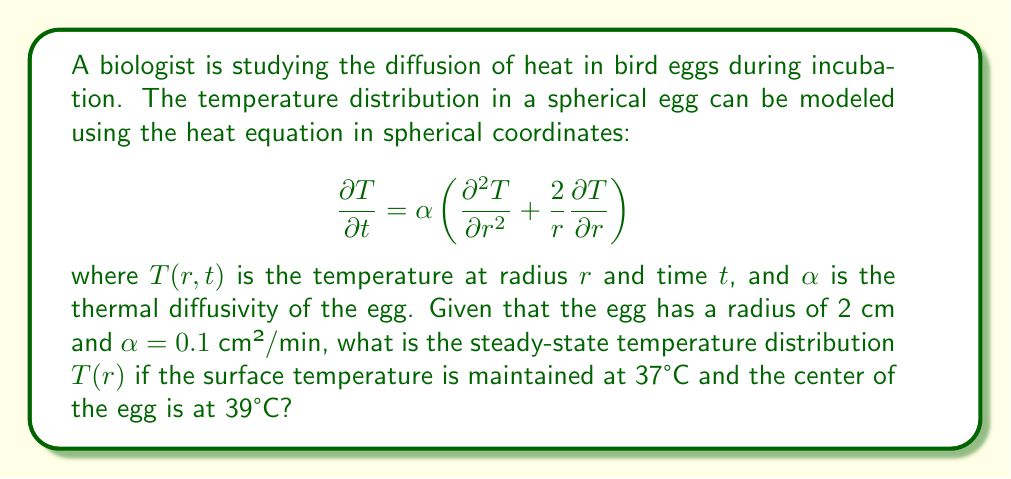What is the answer to this math problem? To solve this problem, we'll follow these steps:

1) For the steady-state solution, $\frac{\partial T}{\partial t} = 0$, so our equation becomes:

   $$0 = \frac{\partial^2 T}{\partial r^2} + \frac{2}{r}\frac{\partial T}{\partial r}$$

2) This can be rewritten as:

   $$\frac{d^2 T}{dr^2} + \frac{2}{r}\frac{dT}{dr} = 0$$

3) Multiply both sides by $r^2$:

   $$r^2\frac{d^2 T}{dr^2} + 2r\frac{dT}{dr} = 0$$

4) This is equivalent to:

   $$\frac{d}{dr}\left(r^2\frac{dT}{dr}\right) = 0$$

5) Integrate once:

   $$r^2\frac{dT}{dr} = C_1$$

6) Divide by $r^2$ and integrate again:

   $$T(r) = -\frac{C_1}{r} + C_2$$

7) Now, apply the boundary conditions:
   At $r = 0$ (center), $T = 39°C$
   At $r = 2$ cm (surface), $T = 37°C$

8) From the first condition:
   $39 = \lim_{r \to 0} (-\frac{C_1}{r} + C_2)$
   This is only possible if $C_1 = 0$, so $C_2 = 39$

9) From the second condition:
   $37 = -\frac{C_1}{2} + C_2$
   $37 = -\frac{C_1}{2} + 39$
   $C_1 = 4$

10) Therefore, the steady-state temperature distribution is:

    $$T(r) = -\frac{4}{r} + 39$$
Answer: $T(r) = -\frac{4}{r} + 39$ 